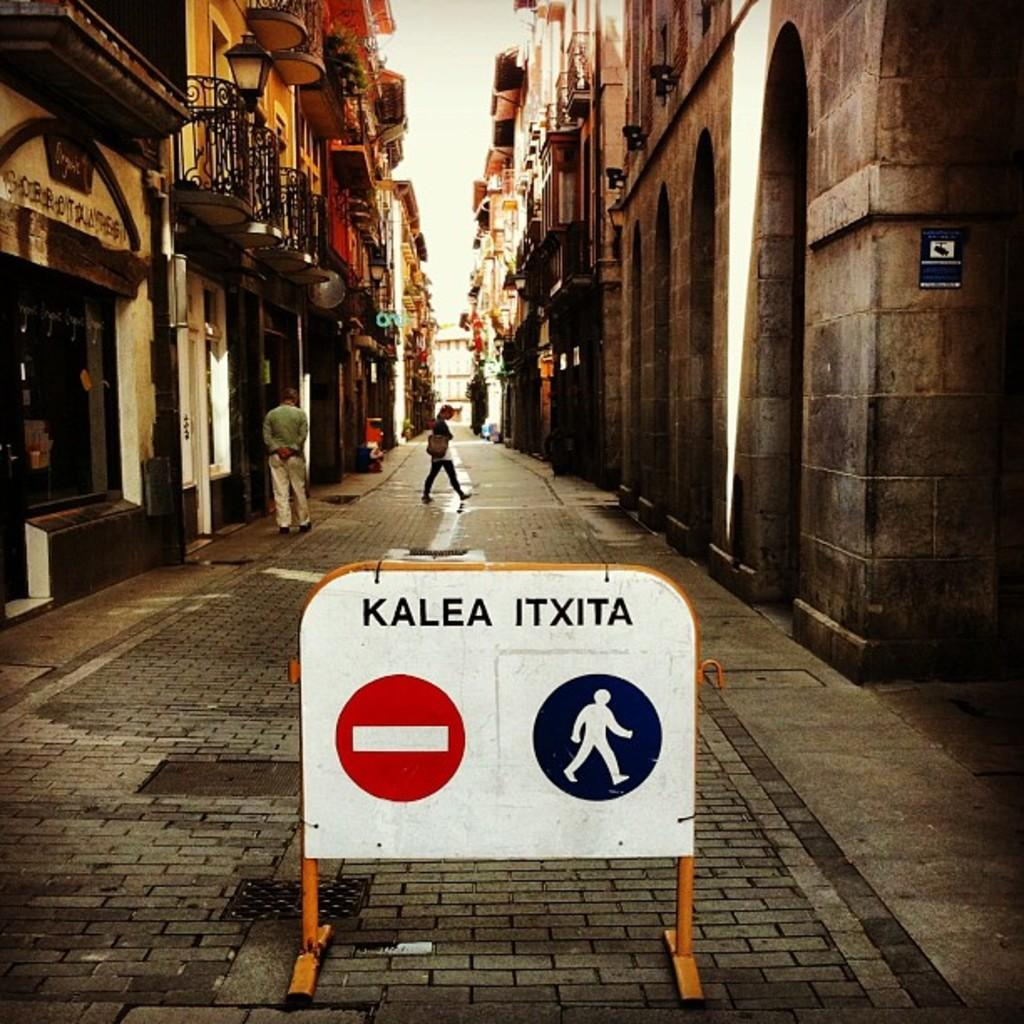<image>
Relay a brief, clear account of the picture shown. A sign reads "kalea itxita" in a roadway. 